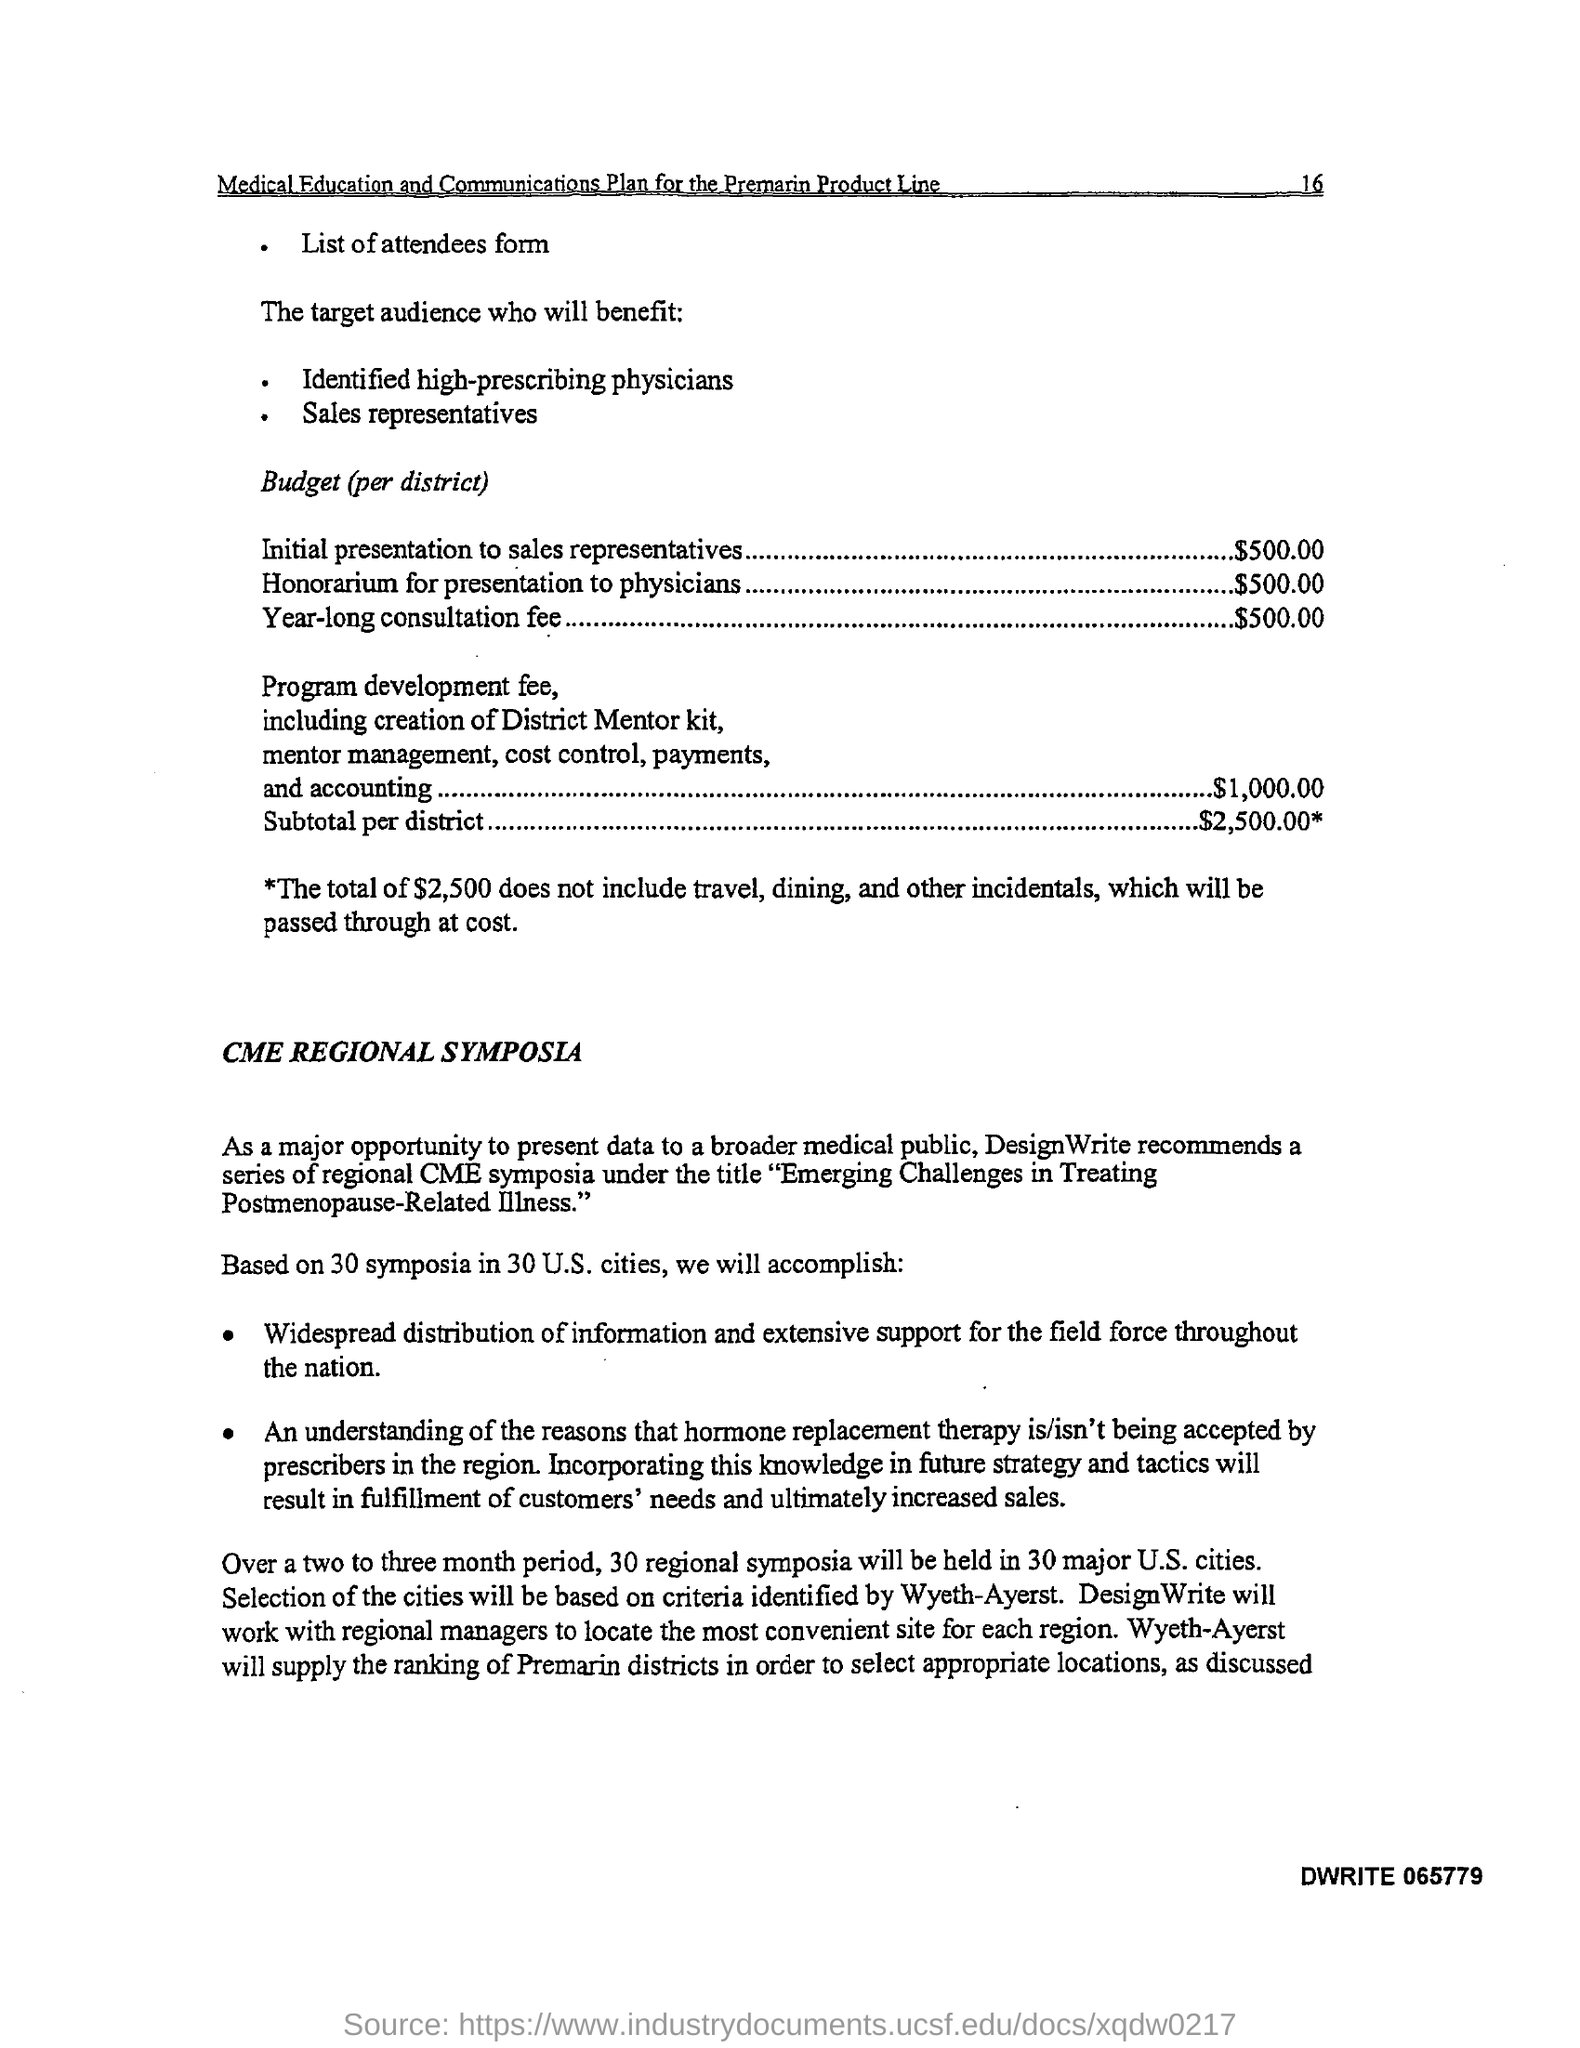What is the budget for initial presentation to sales representatives (per district)?
Provide a succinct answer. $ 500.00. What is the budget given for year long consultation fee (per district) ?
Provide a short and direct response. $500.00. What is the budget given for honorarium for presentation to physicians (per district ) ?
Give a very brief answer. $ 500.00. What is the amount of budget given for subtotal per district ?
Provide a succinct answer. $2,500.00. 